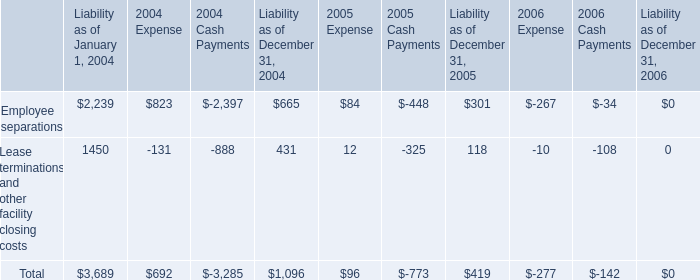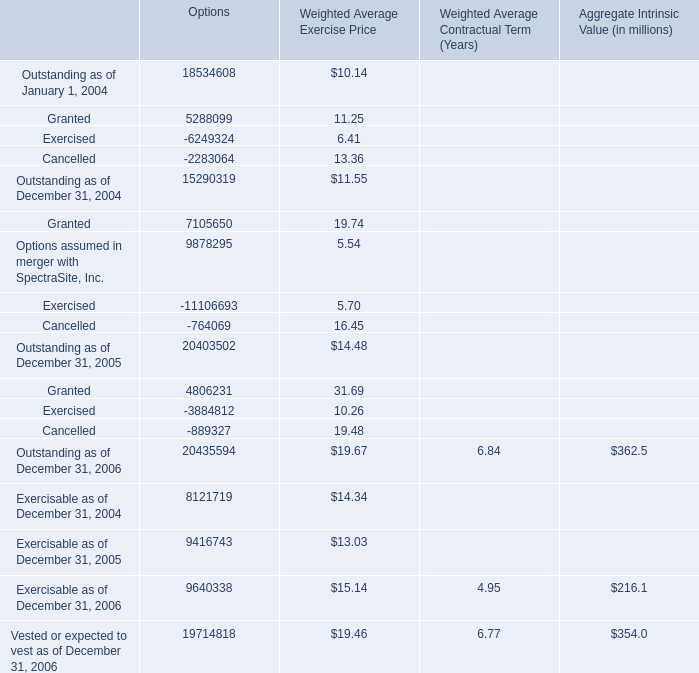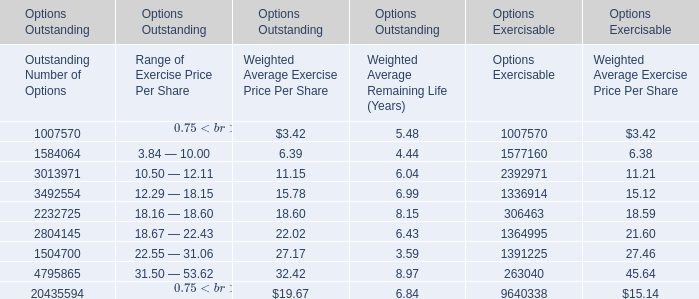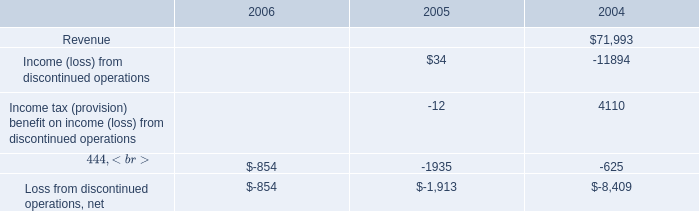In the year with the most options' outstanding as of December 31, what is the growth rate of options' exercisable as of December 31? 
Computations: ((9640338 - 9416743) / 9416743)
Answer: 0.02374. 